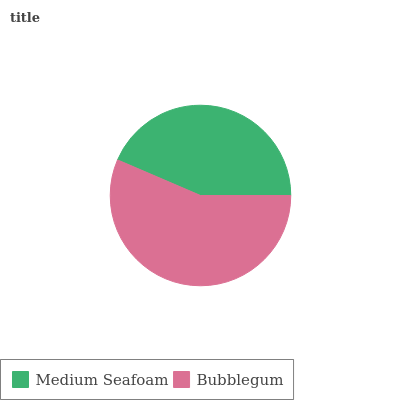Is Medium Seafoam the minimum?
Answer yes or no. Yes. Is Bubblegum the maximum?
Answer yes or no. Yes. Is Bubblegum the minimum?
Answer yes or no. No. Is Bubblegum greater than Medium Seafoam?
Answer yes or no. Yes. Is Medium Seafoam less than Bubblegum?
Answer yes or no. Yes. Is Medium Seafoam greater than Bubblegum?
Answer yes or no. No. Is Bubblegum less than Medium Seafoam?
Answer yes or no. No. Is Bubblegum the high median?
Answer yes or no. Yes. Is Medium Seafoam the low median?
Answer yes or no. Yes. Is Medium Seafoam the high median?
Answer yes or no. No. Is Bubblegum the low median?
Answer yes or no. No. 